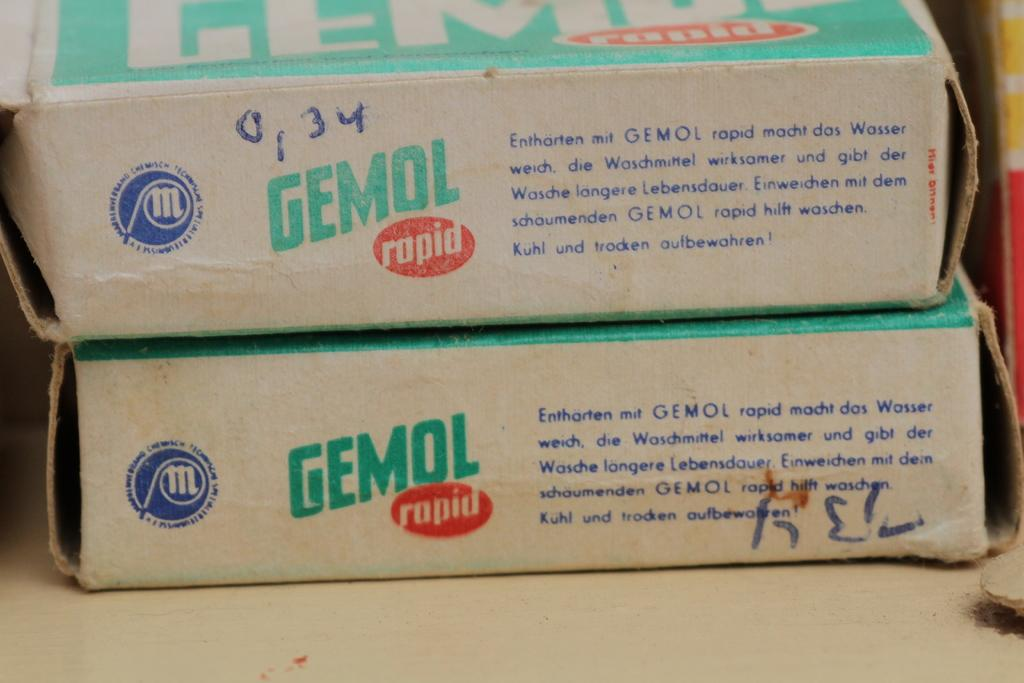What objects are present in the image? There are boxes in the image. What can be seen on the boxes? The boxes have text on them. What type of surface are the boxes placed on? The boxes are placed on a wooden surface. How many cakes are being fought over in the image? There are no cakes or fighting depicted in the image; it only features boxes with text on them placed on a wooden surface. 